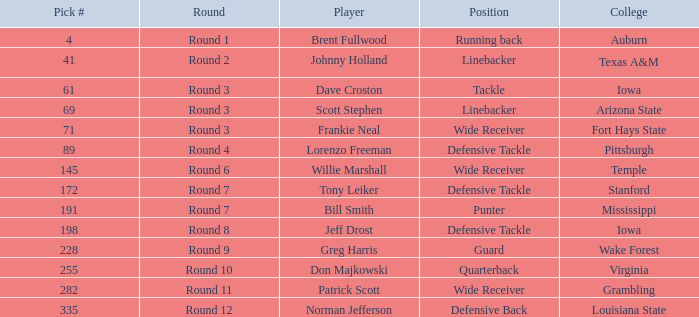What was the pick# for Lorenzo Freeman as defensive tackle? 89.0. 